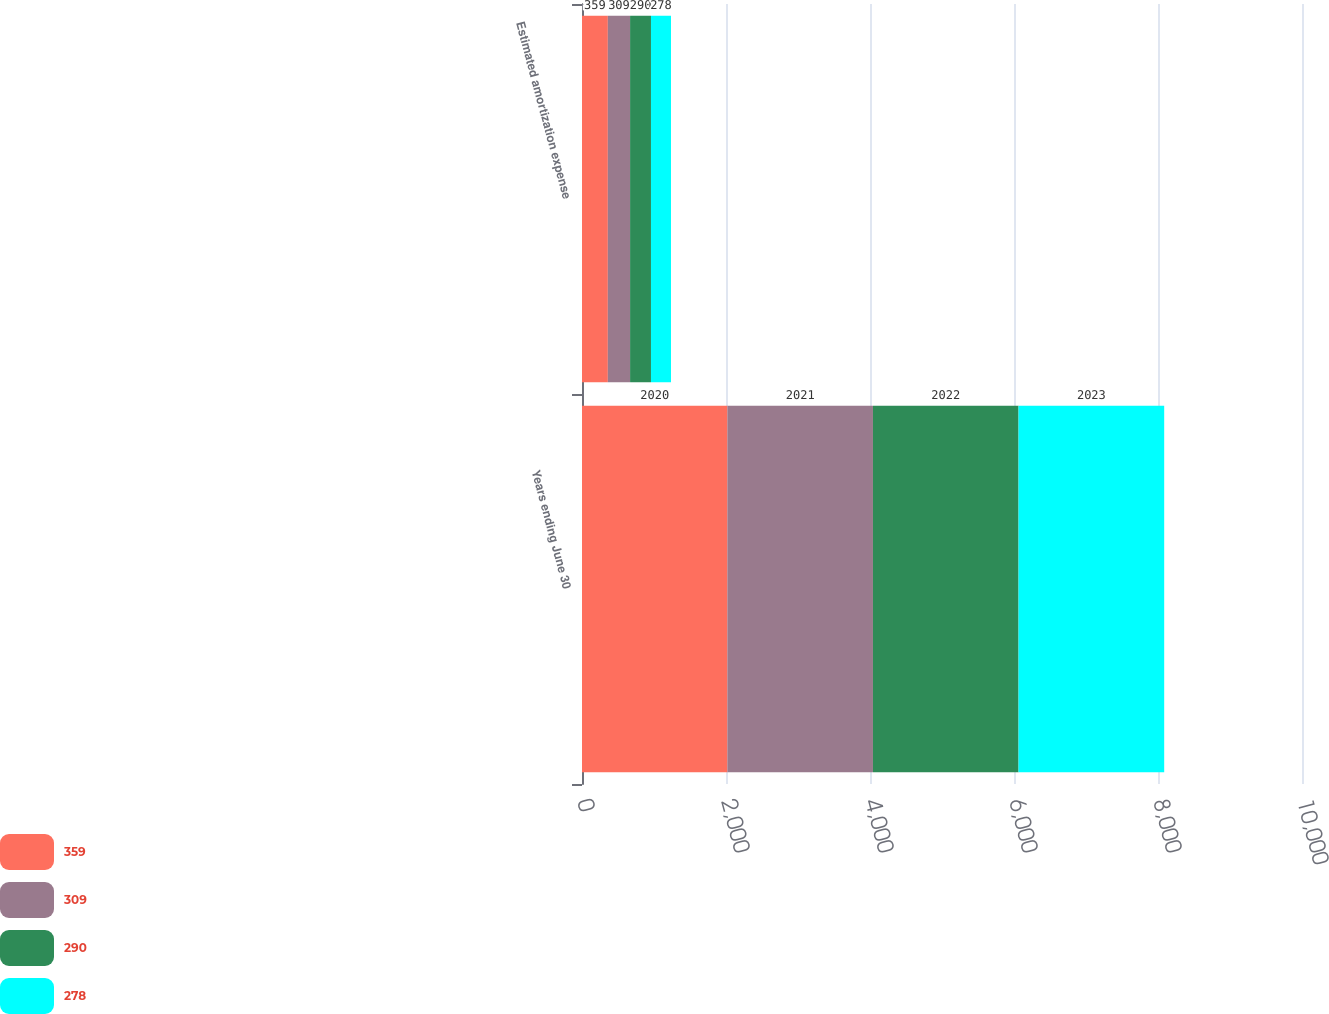Convert chart to OTSL. <chart><loc_0><loc_0><loc_500><loc_500><stacked_bar_chart><ecel><fcel>Years ending June 30<fcel>Estimated amortization expense<nl><fcel>359<fcel>2020<fcel>359<nl><fcel>309<fcel>2021<fcel>309<nl><fcel>290<fcel>2022<fcel>290<nl><fcel>278<fcel>2023<fcel>278<nl></chart> 